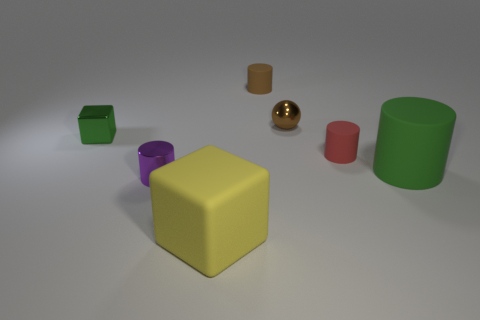The objects have different surfaces; which one looks the shiniest? The shiniest object appears to be the gold sphere. It has a reflective surface that stands out among the other objects with matte finishes. And which one is the most matte in appearance? The red cylinder towards the front looks the most matte, as it does not reflect much light and has a uniformly soft texture. 